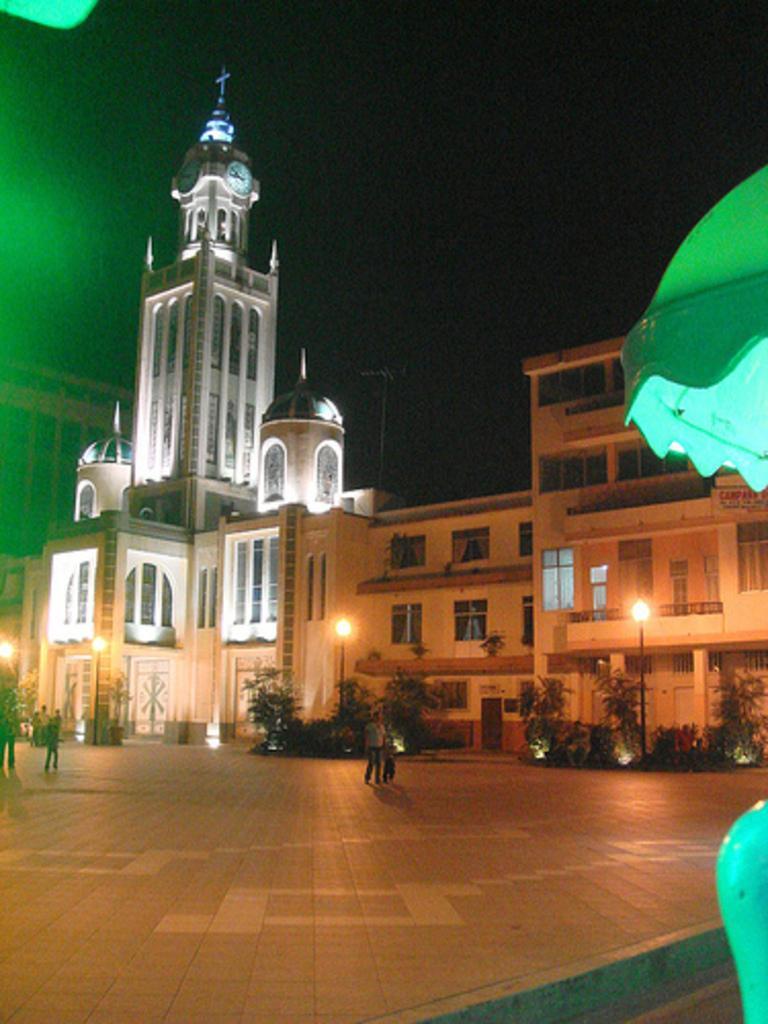Can you describe this image briefly? There are buildings with windows, pillars, balcony and arches. In front of the building there are trees, street light poles and some people are there. In the background it is dark. On the right side there is a green color thing. 